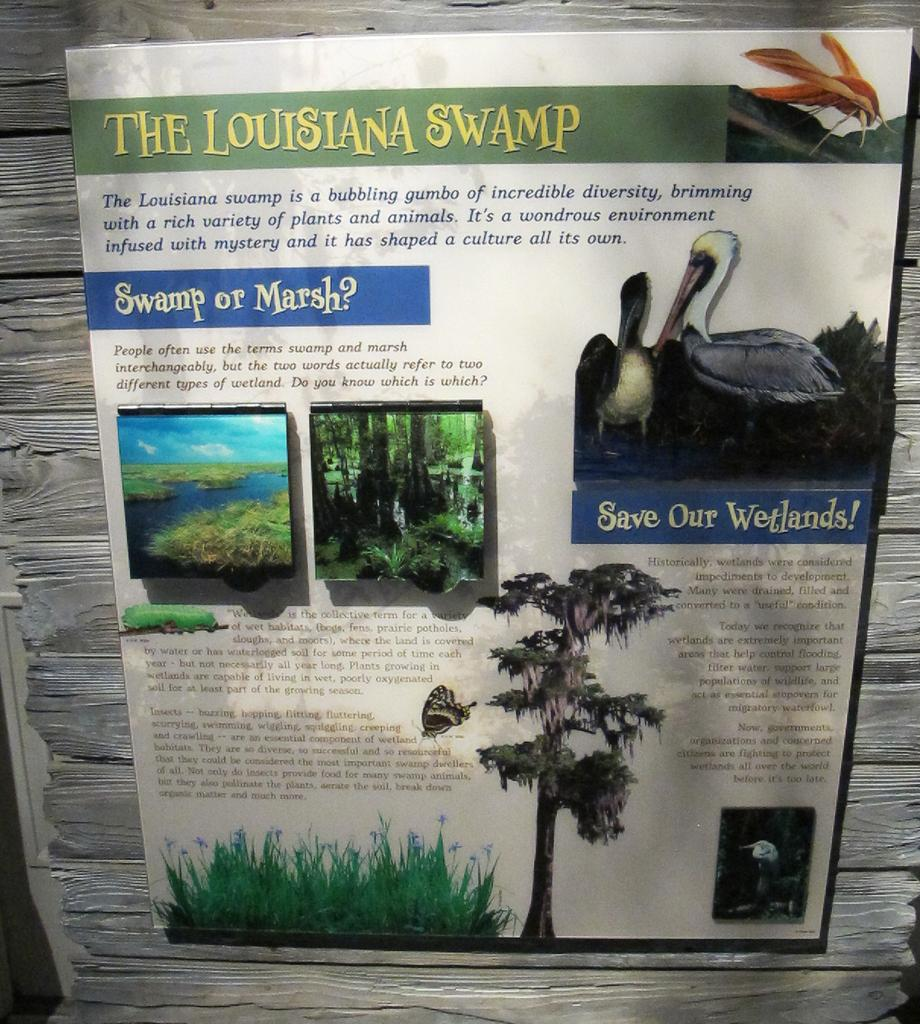What is attached to the wall in the image? There is a paper stuck to the wall in the image. What type of images can be seen on the paper? The paper contains images of birds, trees, and grass. Is there any text on the paper? Yes, there is text on the paper. How much sugar is visible on the paper in the image? There is no sugar visible on the paper in the image. Is there a tiger in the image? No, there is no tiger in the image. 